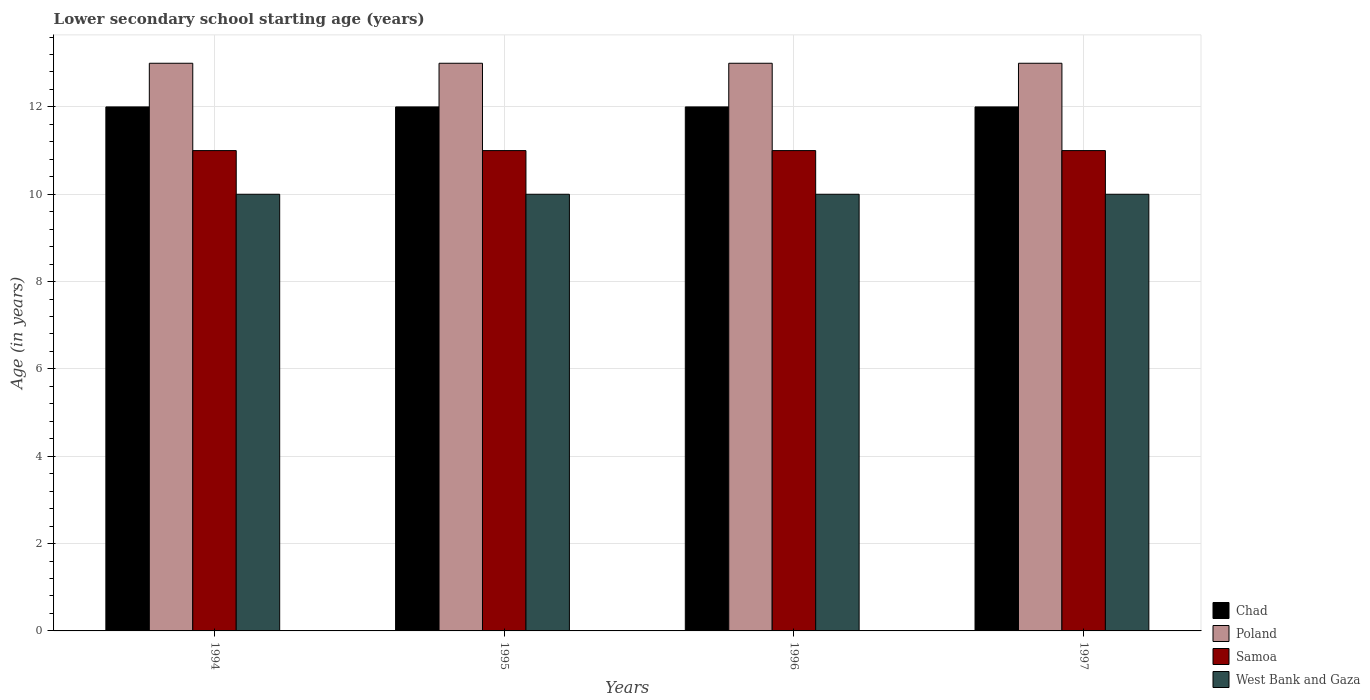Are the number of bars per tick equal to the number of legend labels?
Make the answer very short. Yes. Are the number of bars on each tick of the X-axis equal?
Offer a terse response. Yes. How many bars are there on the 4th tick from the left?
Ensure brevity in your answer.  4. How many bars are there on the 2nd tick from the right?
Provide a short and direct response. 4. What is the label of the 3rd group of bars from the left?
Provide a succinct answer. 1996. What is the lower secondary school starting age of children in Samoa in 1994?
Keep it short and to the point. 11. Across all years, what is the maximum lower secondary school starting age of children in Chad?
Offer a terse response. 12. Across all years, what is the minimum lower secondary school starting age of children in West Bank and Gaza?
Offer a terse response. 10. In which year was the lower secondary school starting age of children in West Bank and Gaza maximum?
Make the answer very short. 1994. In which year was the lower secondary school starting age of children in Chad minimum?
Offer a terse response. 1994. What is the total lower secondary school starting age of children in Samoa in the graph?
Your response must be concise. 44. What is the difference between the lower secondary school starting age of children in Chad in 1994 and that in 1995?
Your answer should be very brief. 0. What is the difference between the lower secondary school starting age of children in Samoa in 1996 and the lower secondary school starting age of children in Chad in 1995?
Offer a terse response. -1. What is the average lower secondary school starting age of children in Chad per year?
Your response must be concise. 12. In the year 1995, what is the difference between the lower secondary school starting age of children in Chad and lower secondary school starting age of children in Samoa?
Provide a short and direct response. 1. In how many years, is the lower secondary school starting age of children in Chad greater than 2.8 years?
Provide a succinct answer. 4. What is the difference between the highest and the second highest lower secondary school starting age of children in Samoa?
Offer a very short reply. 0. What is the difference between the highest and the lowest lower secondary school starting age of children in West Bank and Gaza?
Make the answer very short. 0. In how many years, is the lower secondary school starting age of children in Chad greater than the average lower secondary school starting age of children in Chad taken over all years?
Provide a short and direct response. 0. Is it the case that in every year, the sum of the lower secondary school starting age of children in West Bank and Gaza and lower secondary school starting age of children in Samoa is greater than the sum of lower secondary school starting age of children in Poland and lower secondary school starting age of children in Chad?
Ensure brevity in your answer.  No. What does the 1st bar from the left in 1997 represents?
Provide a succinct answer. Chad. What does the 4th bar from the right in 1996 represents?
Make the answer very short. Chad. How many bars are there?
Provide a succinct answer. 16. Are all the bars in the graph horizontal?
Provide a short and direct response. No. How many years are there in the graph?
Make the answer very short. 4. Are the values on the major ticks of Y-axis written in scientific E-notation?
Your answer should be very brief. No. Does the graph contain any zero values?
Your answer should be compact. No. What is the title of the graph?
Keep it short and to the point. Lower secondary school starting age (years). Does "Czech Republic" appear as one of the legend labels in the graph?
Offer a very short reply. No. What is the label or title of the Y-axis?
Keep it short and to the point. Age (in years). What is the Age (in years) of Samoa in 1994?
Make the answer very short. 11. What is the Age (in years) of West Bank and Gaza in 1994?
Give a very brief answer. 10. What is the Age (in years) of Samoa in 1996?
Keep it short and to the point. 11. What is the Age (in years) of Chad in 1997?
Offer a terse response. 12. What is the Age (in years) in West Bank and Gaza in 1997?
Keep it short and to the point. 10. Across all years, what is the maximum Age (in years) in Chad?
Give a very brief answer. 12. Across all years, what is the maximum Age (in years) in Samoa?
Keep it short and to the point. 11. Across all years, what is the minimum Age (in years) in West Bank and Gaza?
Your answer should be compact. 10. What is the total Age (in years) in West Bank and Gaza in the graph?
Keep it short and to the point. 40. What is the difference between the Age (in years) in West Bank and Gaza in 1994 and that in 1995?
Your answer should be very brief. 0. What is the difference between the Age (in years) of West Bank and Gaza in 1994 and that in 1996?
Keep it short and to the point. 0. What is the difference between the Age (in years) of Chad in 1994 and that in 1997?
Give a very brief answer. 0. What is the difference between the Age (in years) of Samoa in 1994 and that in 1997?
Ensure brevity in your answer.  0. What is the difference between the Age (in years) of Chad in 1995 and that in 1996?
Offer a terse response. 0. What is the difference between the Age (in years) of West Bank and Gaza in 1995 and that in 1996?
Make the answer very short. 0. What is the difference between the Age (in years) of Chad in 1995 and that in 1997?
Make the answer very short. 0. What is the difference between the Age (in years) in Poland in 1995 and that in 1997?
Your response must be concise. 0. What is the difference between the Age (in years) of Samoa in 1995 and that in 1997?
Ensure brevity in your answer.  0. What is the difference between the Age (in years) of West Bank and Gaza in 1995 and that in 1997?
Offer a terse response. 0. What is the difference between the Age (in years) in Chad in 1996 and that in 1997?
Offer a terse response. 0. What is the difference between the Age (in years) in Poland in 1996 and that in 1997?
Ensure brevity in your answer.  0. What is the difference between the Age (in years) in Samoa in 1996 and that in 1997?
Your answer should be very brief. 0. What is the difference between the Age (in years) of Chad in 1994 and the Age (in years) of Poland in 1995?
Your response must be concise. -1. What is the difference between the Age (in years) in Chad in 1994 and the Age (in years) in Samoa in 1995?
Provide a succinct answer. 1. What is the difference between the Age (in years) in Poland in 1994 and the Age (in years) in Samoa in 1995?
Your answer should be compact. 2. What is the difference between the Age (in years) of Poland in 1994 and the Age (in years) of West Bank and Gaza in 1995?
Your answer should be compact. 3. What is the difference between the Age (in years) in Chad in 1994 and the Age (in years) in Poland in 1996?
Provide a short and direct response. -1. What is the difference between the Age (in years) of Chad in 1994 and the Age (in years) of West Bank and Gaza in 1996?
Provide a short and direct response. 2. What is the difference between the Age (in years) in Poland in 1994 and the Age (in years) in West Bank and Gaza in 1996?
Offer a terse response. 3. What is the difference between the Age (in years) of Chad in 1994 and the Age (in years) of Poland in 1997?
Give a very brief answer. -1. What is the difference between the Age (in years) in Chad in 1994 and the Age (in years) in Samoa in 1997?
Your response must be concise. 1. What is the difference between the Age (in years) of Poland in 1994 and the Age (in years) of Samoa in 1997?
Provide a short and direct response. 2. What is the difference between the Age (in years) of Samoa in 1994 and the Age (in years) of West Bank and Gaza in 1997?
Offer a terse response. 1. What is the difference between the Age (in years) of Chad in 1995 and the Age (in years) of Samoa in 1996?
Make the answer very short. 1. What is the difference between the Age (in years) of Poland in 1995 and the Age (in years) of West Bank and Gaza in 1996?
Your answer should be very brief. 3. What is the difference between the Age (in years) of Samoa in 1995 and the Age (in years) of West Bank and Gaza in 1996?
Your answer should be compact. 1. What is the difference between the Age (in years) of Chad in 1995 and the Age (in years) of Samoa in 1997?
Offer a very short reply. 1. What is the difference between the Age (in years) in Chad in 1995 and the Age (in years) in West Bank and Gaza in 1997?
Your response must be concise. 2. What is the difference between the Age (in years) of Poland in 1995 and the Age (in years) of Samoa in 1997?
Offer a very short reply. 2. What is the difference between the Age (in years) of Chad in 1996 and the Age (in years) of West Bank and Gaza in 1997?
Keep it short and to the point. 2. What is the difference between the Age (in years) of Poland in 1996 and the Age (in years) of Samoa in 1997?
Your answer should be compact. 2. What is the average Age (in years) in Poland per year?
Ensure brevity in your answer.  13. What is the average Age (in years) in Samoa per year?
Your answer should be very brief. 11. In the year 1994, what is the difference between the Age (in years) of Chad and Age (in years) of Poland?
Offer a very short reply. -1. In the year 1994, what is the difference between the Age (in years) in Chad and Age (in years) in Samoa?
Offer a terse response. 1. In the year 1994, what is the difference between the Age (in years) in Poland and Age (in years) in West Bank and Gaza?
Your response must be concise. 3. In the year 1995, what is the difference between the Age (in years) of Chad and Age (in years) of Poland?
Provide a succinct answer. -1. In the year 1995, what is the difference between the Age (in years) in Poland and Age (in years) in Samoa?
Make the answer very short. 2. In the year 1996, what is the difference between the Age (in years) in Chad and Age (in years) in West Bank and Gaza?
Ensure brevity in your answer.  2. In the year 1996, what is the difference between the Age (in years) of Poland and Age (in years) of Samoa?
Make the answer very short. 2. In the year 1996, what is the difference between the Age (in years) of Poland and Age (in years) of West Bank and Gaza?
Give a very brief answer. 3. In the year 1996, what is the difference between the Age (in years) of Samoa and Age (in years) of West Bank and Gaza?
Provide a succinct answer. 1. In the year 1997, what is the difference between the Age (in years) in Chad and Age (in years) in Poland?
Offer a terse response. -1. What is the ratio of the Age (in years) in Samoa in 1994 to that in 1995?
Offer a terse response. 1. What is the ratio of the Age (in years) of West Bank and Gaza in 1994 to that in 1996?
Offer a terse response. 1. What is the ratio of the Age (in years) in Chad in 1994 to that in 1997?
Provide a short and direct response. 1. What is the ratio of the Age (in years) in West Bank and Gaza in 1994 to that in 1997?
Provide a short and direct response. 1. What is the ratio of the Age (in years) in Chad in 1995 to that in 1996?
Offer a terse response. 1. What is the ratio of the Age (in years) of Samoa in 1995 to that in 1996?
Your response must be concise. 1. What is the ratio of the Age (in years) of Poland in 1996 to that in 1997?
Keep it short and to the point. 1. What is the ratio of the Age (in years) in West Bank and Gaza in 1996 to that in 1997?
Offer a terse response. 1. What is the difference between the highest and the second highest Age (in years) of Poland?
Your response must be concise. 0. What is the difference between the highest and the lowest Age (in years) in Chad?
Ensure brevity in your answer.  0. 